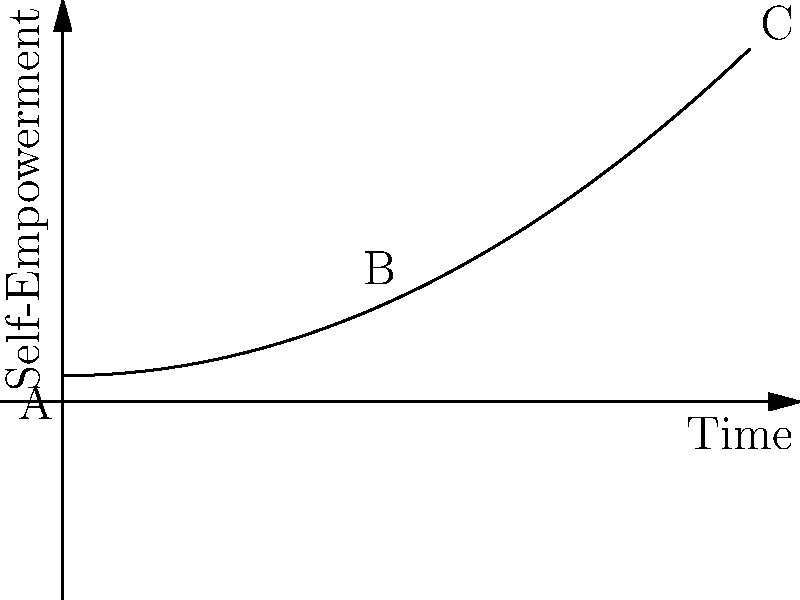In the journey of healing from police brutality, the graph represents your path to self-empowerment over time. Point A marks the beginning of your journey, B represents a significant milestone, and C indicates your current state. If the curve follows the function $f(x) = 0.5x^2 + 1$, where x represents time and f(x) represents the level of self-empowerment, what is the rate of change in self-empowerment at point B? To find the rate of change at point B, we need to follow these steps:

1. Identify the function: $f(x) = 0.5x^2 + 1$

2. Calculate the derivative of the function:
   $f'(x) = \frac{d}{dx}(0.5x^2 + 1) = x$

3. Locate point B:
   Point B is at $x = 2.5$ (halfway between 0 and 5 on the x-axis)

4. Calculate the rate of change at point B by plugging x = 2.5 into the derivative:
   $f'(2.5) = 2.5$

Therefore, the rate of change in self-empowerment at point B is 2.5 units per unit of time.
Answer: 2.5 